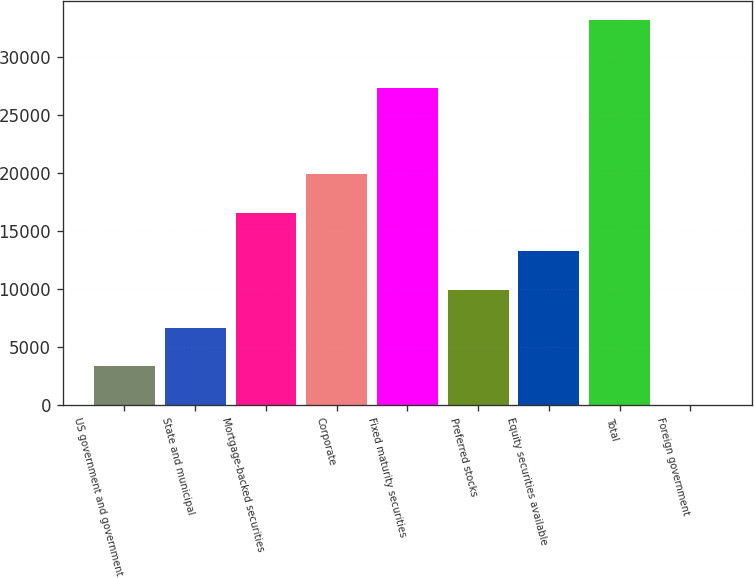Convert chart to OTSL. <chart><loc_0><loc_0><loc_500><loc_500><bar_chart><fcel>US government and government<fcel>State and municipal<fcel>Mortgage-backed securities<fcel>Corporate<fcel>Fixed maturity securities<fcel>Preferred stocks<fcel>Equity securities available<fcel>Total<fcel>Foreign government<nl><fcel>3344.6<fcel>6661.2<fcel>16611<fcel>19927.6<fcel>27388<fcel>9977.8<fcel>13294.4<fcel>33194<fcel>28<nl></chart> 